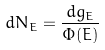<formula> <loc_0><loc_0><loc_500><loc_500>d N _ { E } = \frac { d g _ { E } } { \Phi ( E ) }</formula> 